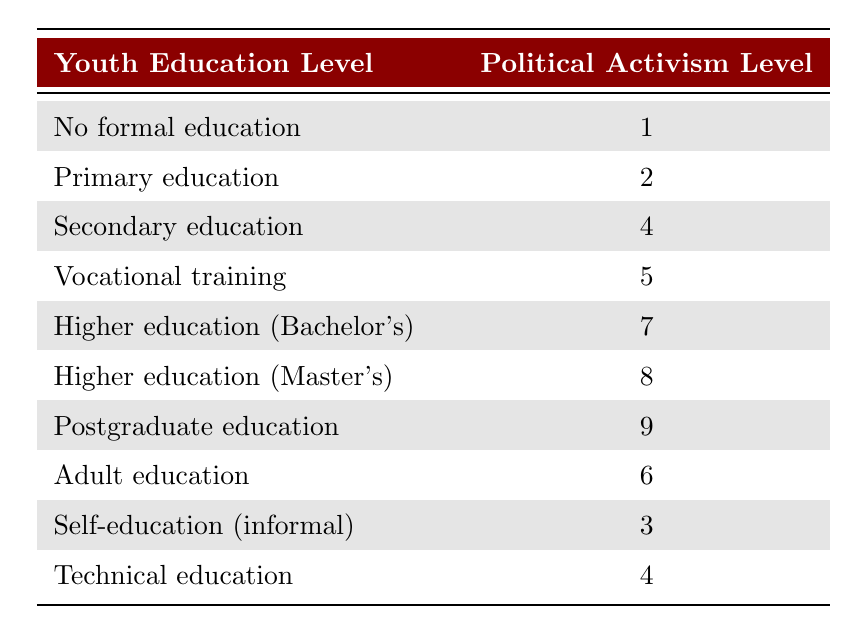What is the political activism level for those with no formal education? By looking at the row corresponding to "No formal education," we see that the political activism level is 1.
Answer: 1 What youth education level corresponds to the highest political activism level? The highest political activism level listed is 9, and it corresponds to "Postgraduate education."
Answer: Postgraduate education What is the political activism level for vocational training? In the row labeled "Vocational training," the political activism level is listed as 5.
Answer: 5 Is there a youth education level that has a political activism level of 3? By checking the table, we see that "Self-education (informal)" has a political activism level of 3, so the answer is yes.
Answer: Yes What is the average political activism level for those with secondary education, adult education, and technical education? The political activism levels for these groups are 4 (secondary education), 6 (adult education), and 4 (technical education). The average is calculated as (4 + 6 + 4) / 3 = 14 / 3 = 4.67, which rounds to 4.67.
Answer: 4.67 How many levels of youth education have a political activism level greater than 5? The levels greater than 5 are: Higher education (Bachelor's) at 7, Higher education (Master's) at 8, and Postgraduate education at 9. That totals to 3 levels.
Answer: 3 What is the difference between the highest and the lowest political activism levels? The highest level is 9 (Postgraduate education) and the lowest is 1 (No formal education). The difference is 9 - 1 = 8.
Answer: 8 What political activism level do graduates of higher education (Bachelor's) have compared to those with adult education? The political activism level for higher education (Bachelor's) is 7, while for adult education it is 6. The comparison shows that higher education (Bachelor's) has a higher level of 1 more than adult education.
Answer: 1 more Is the political activism level for those with privileged higher education consistently highest across all education types? No, while "Postgraduate education" has the highest level of 9, "Higher education (Bachelor's)" and "Higher education (Master's)" also have high levels, but not consistently the absolute highest among all groups.
Answer: No 